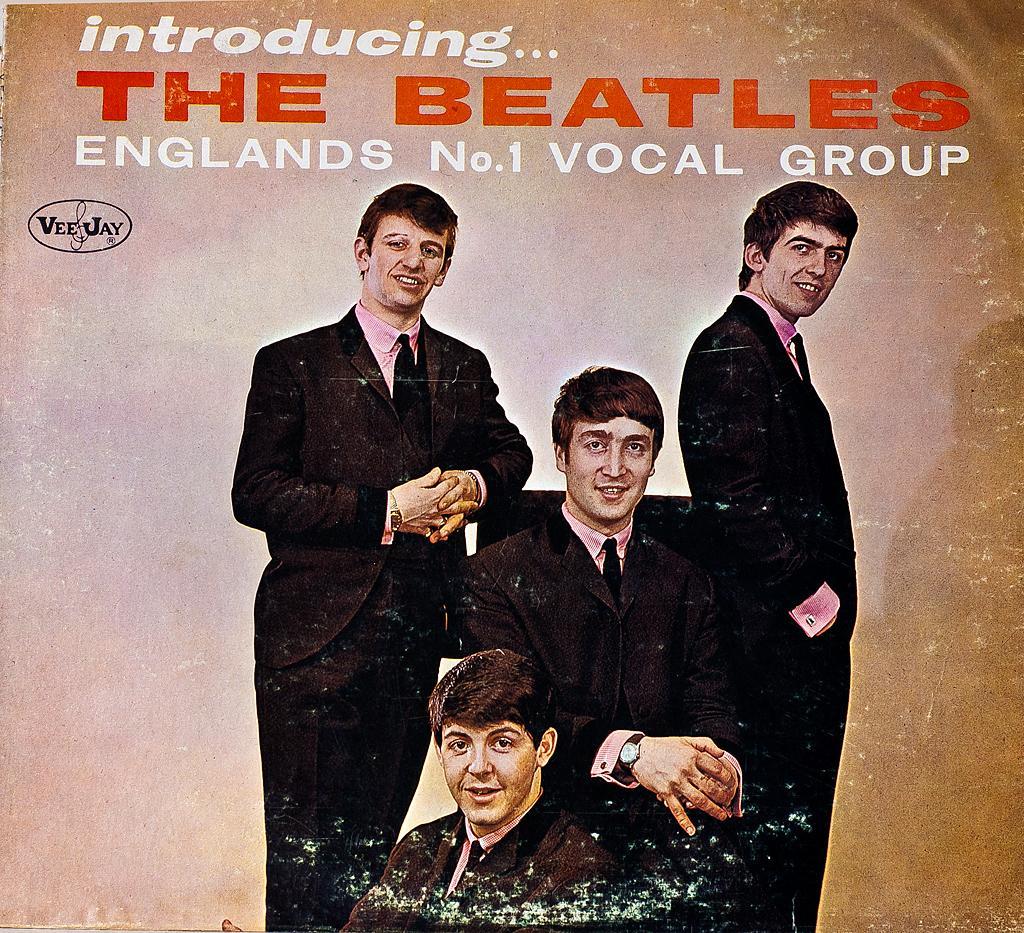Can you describe this image briefly? It is a poster. In this image, we can see four people. They are watching and smiling. Here a person is sitting on the chair. Top of the image, we can see some text. 